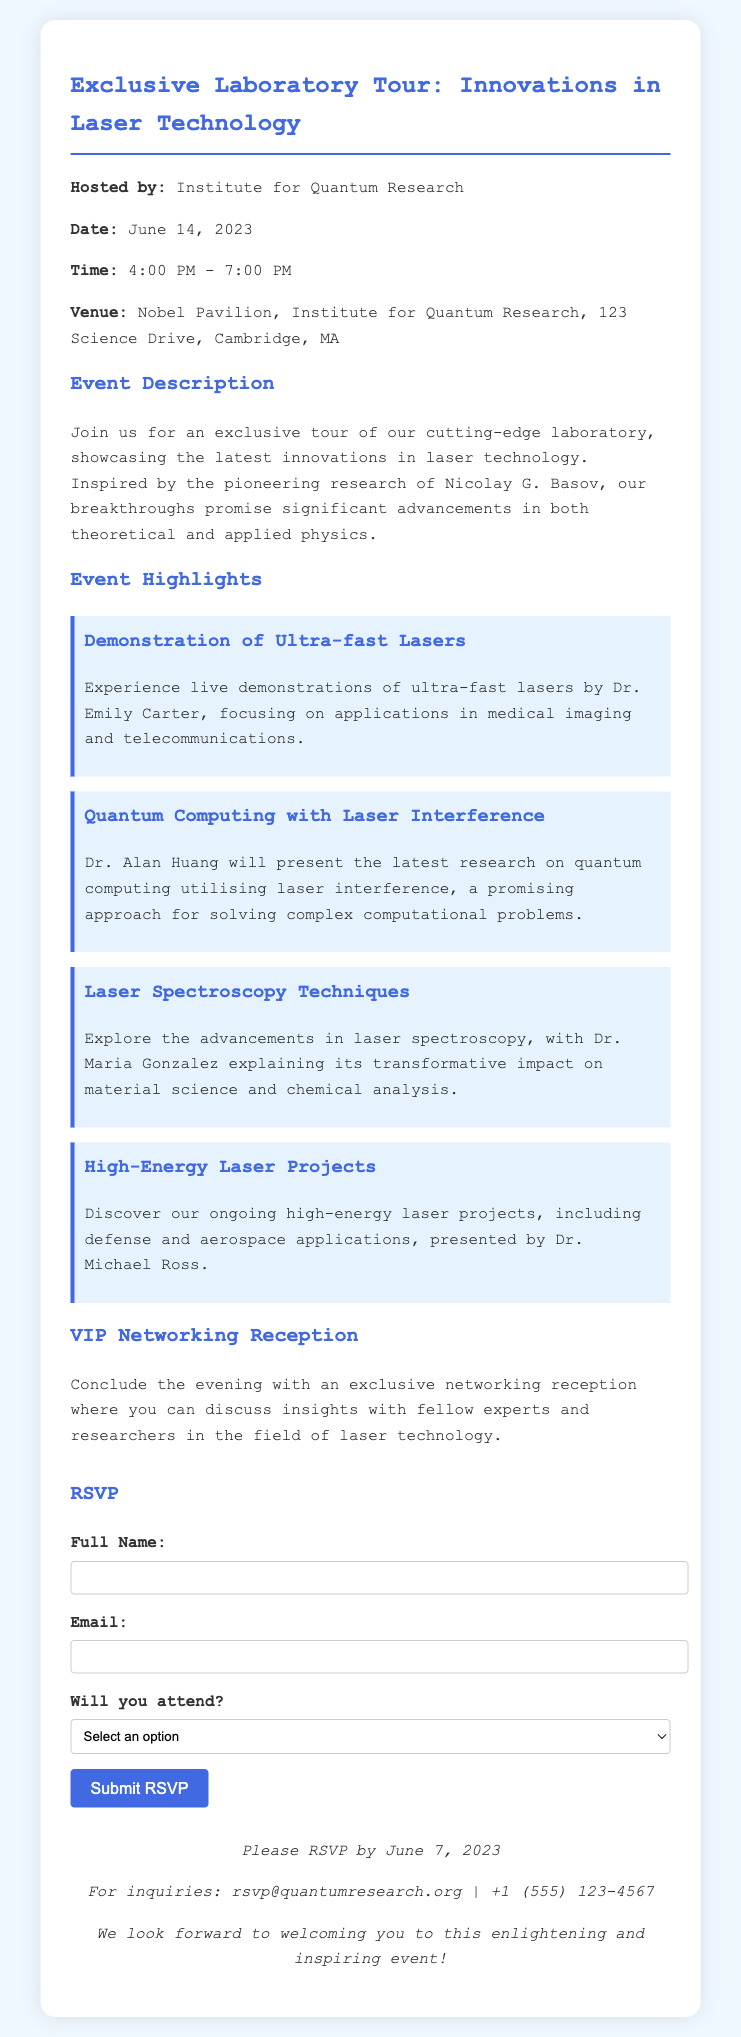What is the date of the event? The date of the event is explicitly mentioned in the document.
Answer: June 14, 2023 Who is hosting the event? The hosting organization is identified in the document.
Answer: Institute for Quantum Research What time does the event start? The starting time of the event is stated clearly in the document.
Answer: 4:00 PM Which venue is the event held at? The venue is specified in the document, including the address.
Answer: Nobel Pavilion, Institute for Quantum Research What is one application of ultra-fast lasers mentioned? The document discusses applications of ultra-fast lasers.
Answer: Medical imaging What should attendees do by June 7, 2023? The deadline for attendees is outlined in the document.
Answer: RSVP Who presents the advancements in laser spectroscopy? The document names the presenter during the event highlights.
Answer: Dr. Maria Gonzalez What type of reception follows the tour? The type of event at the end of the program is described in the document.
Answer: Networking reception How can inquiries be directed? The contact information for inquiries is provided in the document.
Answer: rsvp@quantumresearch.org 